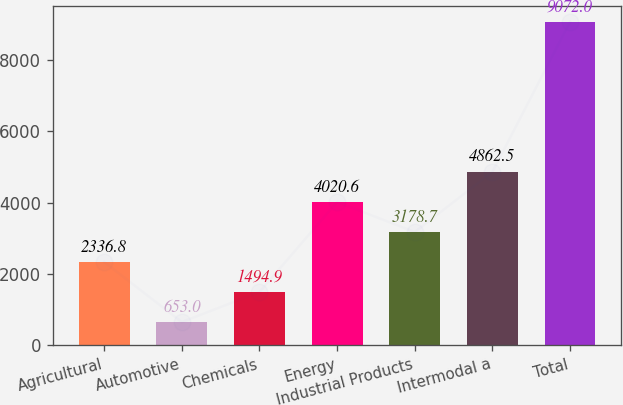Convert chart. <chart><loc_0><loc_0><loc_500><loc_500><bar_chart><fcel>Agricultural<fcel>Automotive<fcel>Chemicals<fcel>Energy<fcel>Industrial Products<fcel>Intermodal a<fcel>Total<nl><fcel>2336.8<fcel>653<fcel>1494.9<fcel>4020.6<fcel>3178.7<fcel>4862.5<fcel>9072<nl></chart> 